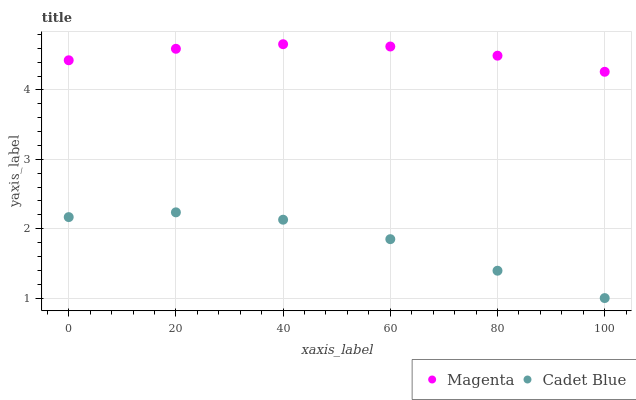Does Cadet Blue have the minimum area under the curve?
Answer yes or no. Yes. Does Magenta have the maximum area under the curve?
Answer yes or no. Yes. Does Cadet Blue have the maximum area under the curve?
Answer yes or no. No. Is Magenta the smoothest?
Answer yes or no. Yes. Is Cadet Blue the roughest?
Answer yes or no. Yes. Is Cadet Blue the smoothest?
Answer yes or no. No. Does Cadet Blue have the lowest value?
Answer yes or no. Yes. Does Magenta have the highest value?
Answer yes or no. Yes. Does Cadet Blue have the highest value?
Answer yes or no. No. Is Cadet Blue less than Magenta?
Answer yes or no. Yes. Is Magenta greater than Cadet Blue?
Answer yes or no. Yes. Does Cadet Blue intersect Magenta?
Answer yes or no. No. 